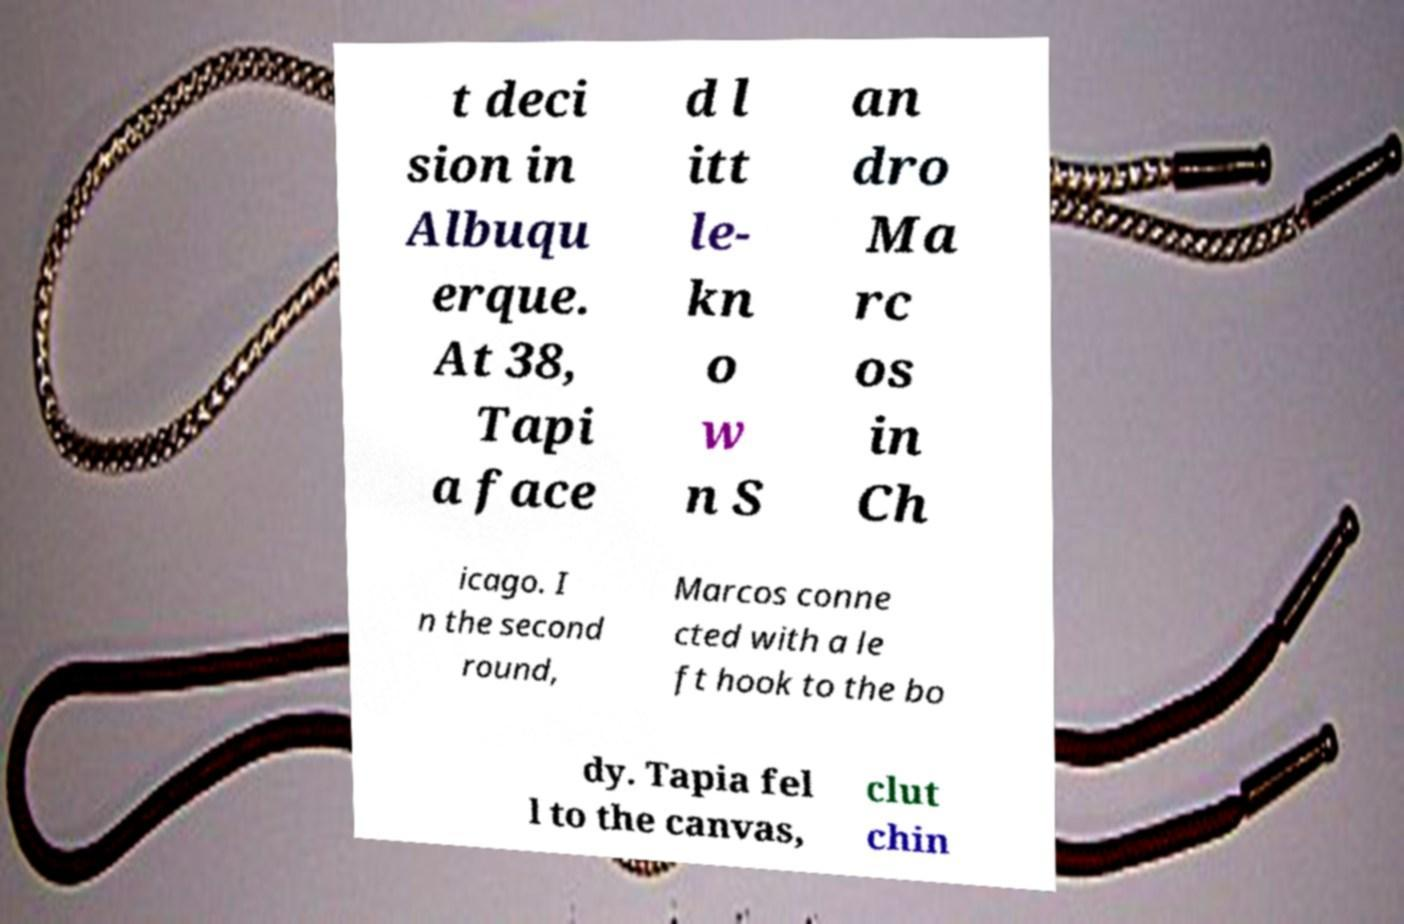Can you accurately transcribe the text from the provided image for me? t deci sion in Albuqu erque. At 38, Tapi a face d l itt le- kn o w n S an dro Ma rc os in Ch icago. I n the second round, Marcos conne cted with a le ft hook to the bo dy. Tapia fel l to the canvas, clut chin 